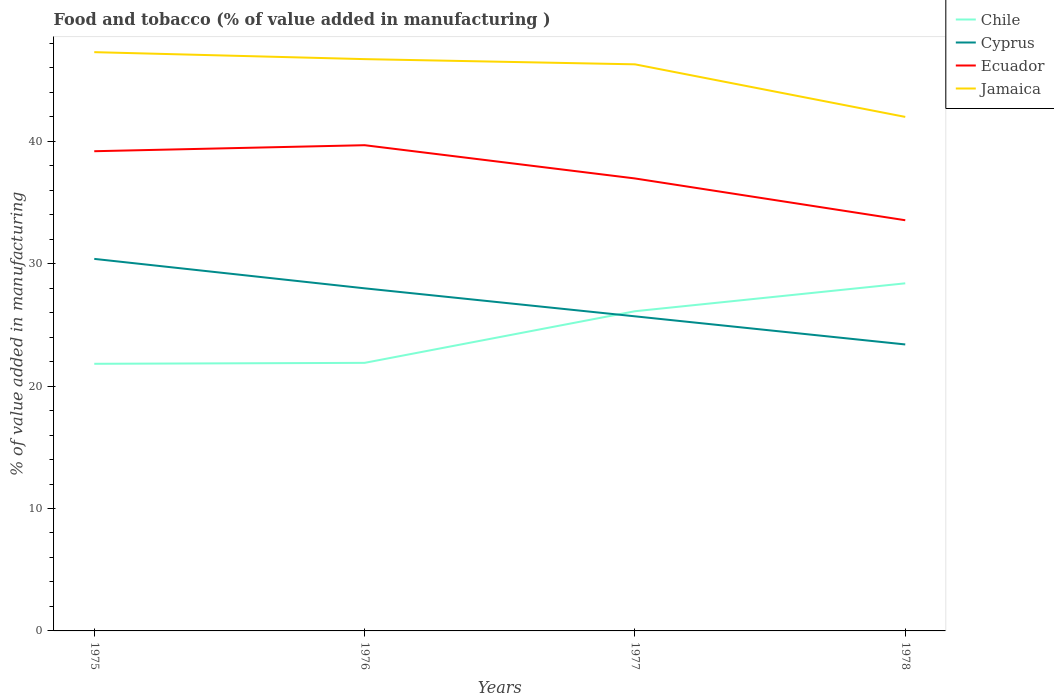How many different coloured lines are there?
Offer a very short reply. 4. Does the line corresponding to Jamaica intersect with the line corresponding to Chile?
Your response must be concise. No. Across all years, what is the maximum value added in manufacturing food and tobacco in Ecuador?
Offer a very short reply. 33.54. In which year was the value added in manufacturing food and tobacco in Chile maximum?
Your answer should be very brief. 1975. What is the total value added in manufacturing food and tobacco in Chile in the graph?
Offer a very short reply. -4.22. What is the difference between the highest and the second highest value added in manufacturing food and tobacco in Chile?
Your answer should be very brief. 6.57. What is the difference between the highest and the lowest value added in manufacturing food and tobacco in Ecuador?
Keep it short and to the point. 2. Is the value added in manufacturing food and tobacco in Jamaica strictly greater than the value added in manufacturing food and tobacco in Chile over the years?
Keep it short and to the point. No. How many lines are there?
Your response must be concise. 4. What is the difference between two consecutive major ticks on the Y-axis?
Your answer should be compact. 10. Where does the legend appear in the graph?
Your answer should be very brief. Top right. How are the legend labels stacked?
Make the answer very short. Vertical. What is the title of the graph?
Your answer should be very brief. Food and tobacco (% of value added in manufacturing ). Does "Vanuatu" appear as one of the legend labels in the graph?
Offer a very short reply. No. What is the label or title of the Y-axis?
Your answer should be very brief. % of value added in manufacturing. What is the % of value added in manufacturing of Chile in 1975?
Make the answer very short. 21.82. What is the % of value added in manufacturing of Cyprus in 1975?
Offer a terse response. 30.39. What is the % of value added in manufacturing in Ecuador in 1975?
Your answer should be very brief. 39.18. What is the % of value added in manufacturing of Jamaica in 1975?
Your response must be concise. 47.27. What is the % of value added in manufacturing in Chile in 1976?
Your response must be concise. 21.89. What is the % of value added in manufacturing of Cyprus in 1976?
Ensure brevity in your answer.  27.98. What is the % of value added in manufacturing in Ecuador in 1976?
Your answer should be very brief. 39.67. What is the % of value added in manufacturing in Jamaica in 1976?
Your answer should be very brief. 46.7. What is the % of value added in manufacturing in Chile in 1977?
Your answer should be compact. 26.11. What is the % of value added in manufacturing in Cyprus in 1977?
Give a very brief answer. 25.7. What is the % of value added in manufacturing of Ecuador in 1977?
Give a very brief answer. 36.96. What is the % of value added in manufacturing of Jamaica in 1977?
Keep it short and to the point. 46.28. What is the % of value added in manufacturing in Chile in 1978?
Provide a succinct answer. 28.39. What is the % of value added in manufacturing of Cyprus in 1978?
Provide a short and direct response. 23.4. What is the % of value added in manufacturing of Ecuador in 1978?
Keep it short and to the point. 33.54. What is the % of value added in manufacturing in Jamaica in 1978?
Offer a very short reply. 41.98. Across all years, what is the maximum % of value added in manufacturing in Chile?
Provide a succinct answer. 28.39. Across all years, what is the maximum % of value added in manufacturing in Cyprus?
Your answer should be compact. 30.39. Across all years, what is the maximum % of value added in manufacturing in Ecuador?
Offer a terse response. 39.67. Across all years, what is the maximum % of value added in manufacturing of Jamaica?
Your response must be concise. 47.27. Across all years, what is the minimum % of value added in manufacturing in Chile?
Ensure brevity in your answer.  21.82. Across all years, what is the minimum % of value added in manufacturing of Cyprus?
Give a very brief answer. 23.4. Across all years, what is the minimum % of value added in manufacturing of Ecuador?
Offer a terse response. 33.54. Across all years, what is the minimum % of value added in manufacturing in Jamaica?
Your response must be concise. 41.98. What is the total % of value added in manufacturing in Chile in the graph?
Ensure brevity in your answer.  98.22. What is the total % of value added in manufacturing in Cyprus in the graph?
Give a very brief answer. 107.46. What is the total % of value added in manufacturing of Ecuador in the graph?
Make the answer very short. 149.36. What is the total % of value added in manufacturing in Jamaica in the graph?
Keep it short and to the point. 182.24. What is the difference between the % of value added in manufacturing of Chile in 1975 and that in 1976?
Offer a terse response. -0.08. What is the difference between the % of value added in manufacturing of Cyprus in 1975 and that in 1976?
Give a very brief answer. 2.4. What is the difference between the % of value added in manufacturing of Ecuador in 1975 and that in 1976?
Give a very brief answer. -0.49. What is the difference between the % of value added in manufacturing in Jamaica in 1975 and that in 1976?
Ensure brevity in your answer.  0.57. What is the difference between the % of value added in manufacturing of Chile in 1975 and that in 1977?
Offer a terse response. -4.29. What is the difference between the % of value added in manufacturing of Cyprus in 1975 and that in 1977?
Keep it short and to the point. 4.69. What is the difference between the % of value added in manufacturing in Ecuador in 1975 and that in 1977?
Offer a terse response. 2.22. What is the difference between the % of value added in manufacturing in Chile in 1975 and that in 1978?
Offer a very short reply. -6.57. What is the difference between the % of value added in manufacturing in Cyprus in 1975 and that in 1978?
Provide a short and direct response. 6.99. What is the difference between the % of value added in manufacturing in Ecuador in 1975 and that in 1978?
Your response must be concise. 5.64. What is the difference between the % of value added in manufacturing of Jamaica in 1975 and that in 1978?
Make the answer very short. 5.29. What is the difference between the % of value added in manufacturing of Chile in 1976 and that in 1977?
Ensure brevity in your answer.  -4.22. What is the difference between the % of value added in manufacturing of Cyprus in 1976 and that in 1977?
Give a very brief answer. 2.29. What is the difference between the % of value added in manufacturing in Ecuador in 1976 and that in 1977?
Offer a very short reply. 2.72. What is the difference between the % of value added in manufacturing in Jamaica in 1976 and that in 1977?
Provide a short and direct response. 0.43. What is the difference between the % of value added in manufacturing in Chile in 1976 and that in 1978?
Provide a succinct answer. -6.5. What is the difference between the % of value added in manufacturing of Cyprus in 1976 and that in 1978?
Keep it short and to the point. 4.58. What is the difference between the % of value added in manufacturing of Ecuador in 1976 and that in 1978?
Ensure brevity in your answer.  6.13. What is the difference between the % of value added in manufacturing in Jamaica in 1976 and that in 1978?
Your answer should be compact. 4.72. What is the difference between the % of value added in manufacturing of Chile in 1977 and that in 1978?
Provide a succinct answer. -2.28. What is the difference between the % of value added in manufacturing of Cyprus in 1977 and that in 1978?
Offer a terse response. 2.3. What is the difference between the % of value added in manufacturing of Ecuador in 1977 and that in 1978?
Provide a short and direct response. 3.41. What is the difference between the % of value added in manufacturing in Jamaica in 1977 and that in 1978?
Ensure brevity in your answer.  4.29. What is the difference between the % of value added in manufacturing in Chile in 1975 and the % of value added in manufacturing in Cyprus in 1976?
Ensure brevity in your answer.  -6.16. What is the difference between the % of value added in manufacturing of Chile in 1975 and the % of value added in manufacturing of Ecuador in 1976?
Your answer should be compact. -17.85. What is the difference between the % of value added in manufacturing in Chile in 1975 and the % of value added in manufacturing in Jamaica in 1976?
Keep it short and to the point. -24.88. What is the difference between the % of value added in manufacturing in Cyprus in 1975 and the % of value added in manufacturing in Ecuador in 1976?
Your response must be concise. -9.29. What is the difference between the % of value added in manufacturing of Cyprus in 1975 and the % of value added in manufacturing of Jamaica in 1976?
Keep it short and to the point. -16.32. What is the difference between the % of value added in manufacturing in Ecuador in 1975 and the % of value added in manufacturing in Jamaica in 1976?
Your answer should be very brief. -7.52. What is the difference between the % of value added in manufacturing in Chile in 1975 and the % of value added in manufacturing in Cyprus in 1977?
Give a very brief answer. -3.88. What is the difference between the % of value added in manufacturing of Chile in 1975 and the % of value added in manufacturing of Ecuador in 1977?
Offer a very short reply. -15.14. What is the difference between the % of value added in manufacturing of Chile in 1975 and the % of value added in manufacturing of Jamaica in 1977?
Give a very brief answer. -24.46. What is the difference between the % of value added in manufacturing in Cyprus in 1975 and the % of value added in manufacturing in Ecuador in 1977?
Ensure brevity in your answer.  -6.57. What is the difference between the % of value added in manufacturing in Cyprus in 1975 and the % of value added in manufacturing in Jamaica in 1977?
Provide a short and direct response. -15.89. What is the difference between the % of value added in manufacturing in Ecuador in 1975 and the % of value added in manufacturing in Jamaica in 1977?
Keep it short and to the point. -7.1. What is the difference between the % of value added in manufacturing in Chile in 1975 and the % of value added in manufacturing in Cyprus in 1978?
Offer a terse response. -1.58. What is the difference between the % of value added in manufacturing in Chile in 1975 and the % of value added in manufacturing in Ecuador in 1978?
Your answer should be compact. -11.73. What is the difference between the % of value added in manufacturing in Chile in 1975 and the % of value added in manufacturing in Jamaica in 1978?
Ensure brevity in your answer.  -20.16. What is the difference between the % of value added in manufacturing of Cyprus in 1975 and the % of value added in manufacturing of Ecuador in 1978?
Offer a terse response. -3.16. What is the difference between the % of value added in manufacturing in Cyprus in 1975 and the % of value added in manufacturing in Jamaica in 1978?
Provide a short and direct response. -11.6. What is the difference between the % of value added in manufacturing of Ecuador in 1975 and the % of value added in manufacturing of Jamaica in 1978?
Give a very brief answer. -2.8. What is the difference between the % of value added in manufacturing of Chile in 1976 and the % of value added in manufacturing of Cyprus in 1977?
Make the answer very short. -3.8. What is the difference between the % of value added in manufacturing in Chile in 1976 and the % of value added in manufacturing in Ecuador in 1977?
Your answer should be very brief. -15.06. What is the difference between the % of value added in manufacturing in Chile in 1976 and the % of value added in manufacturing in Jamaica in 1977?
Provide a succinct answer. -24.38. What is the difference between the % of value added in manufacturing in Cyprus in 1976 and the % of value added in manufacturing in Ecuador in 1977?
Give a very brief answer. -8.97. What is the difference between the % of value added in manufacturing of Cyprus in 1976 and the % of value added in manufacturing of Jamaica in 1977?
Keep it short and to the point. -18.3. What is the difference between the % of value added in manufacturing of Ecuador in 1976 and the % of value added in manufacturing of Jamaica in 1977?
Offer a terse response. -6.61. What is the difference between the % of value added in manufacturing of Chile in 1976 and the % of value added in manufacturing of Cyprus in 1978?
Ensure brevity in your answer.  -1.5. What is the difference between the % of value added in manufacturing in Chile in 1976 and the % of value added in manufacturing in Ecuador in 1978?
Provide a short and direct response. -11.65. What is the difference between the % of value added in manufacturing of Chile in 1976 and the % of value added in manufacturing of Jamaica in 1978?
Provide a short and direct response. -20.09. What is the difference between the % of value added in manufacturing of Cyprus in 1976 and the % of value added in manufacturing of Ecuador in 1978?
Provide a succinct answer. -5.56. What is the difference between the % of value added in manufacturing of Cyprus in 1976 and the % of value added in manufacturing of Jamaica in 1978?
Provide a succinct answer. -14. What is the difference between the % of value added in manufacturing in Ecuador in 1976 and the % of value added in manufacturing in Jamaica in 1978?
Ensure brevity in your answer.  -2.31. What is the difference between the % of value added in manufacturing in Chile in 1977 and the % of value added in manufacturing in Cyprus in 1978?
Provide a short and direct response. 2.71. What is the difference between the % of value added in manufacturing of Chile in 1977 and the % of value added in manufacturing of Ecuador in 1978?
Your answer should be compact. -7.43. What is the difference between the % of value added in manufacturing in Chile in 1977 and the % of value added in manufacturing in Jamaica in 1978?
Make the answer very short. -15.87. What is the difference between the % of value added in manufacturing in Cyprus in 1977 and the % of value added in manufacturing in Ecuador in 1978?
Ensure brevity in your answer.  -7.85. What is the difference between the % of value added in manufacturing in Cyprus in 1977 and the % of value added in manufacturing in Jamaica in 1978?
Provide a short and direct response. -16.29. What is the difference between the % of value added in manufacturing of Ecuador in 1977 and the % of value added in manufacturing of Jamaica in 1978?
Offer a very short reply. -5.03. What is the average % of value added in manufacturing in Chile per year?
Offer a very short reply. 24.55. What is the average % of value added in manufacturing in Cyprus per year?
Provide a short and direct response. 26.87. What is the average % of value added in manufacturing in Ecuador per year?
Offer a terse response. 37.34. What is the average % of value added in manufacturing of Jamaica per year?
Make the answer very short. 45.56. In the year 1975, what is the difference between the % of value added in manufacturing in Chile and % of value added in manufacturing in Cyprus?
Provide a short and direct response. -8.57. In the year 1975, what is the difference between the % of value added in manufacturing in Chile and % of value added in manufacturing in Ecuador?
Your answer should be compact. -17.36. In the year 1975, what is the difference between the % of value added in manufacturing in Chile and % of value added in manufacturing in Jamaica?
Offer a terse response. -25.45. In the year 1975, what is the difference between the % of value added in manufacturing in Cyprus and % of value added in manufacturing in Ecuador?
Your response must be concise. -8.79. In the year 1975, what is the difference between the % of value added in manufacturing in Cyprus and % of value added in manufacturing in Jamaica?
Your response must be concise. -16.89. In the year 1975, what is the difference between the % of value added in manufacturing of Ecuador and % of value added in manufacturing of Jamaica?
Ensure brevity in your answer.  -8.09. In the year 1976, what is the difference between the % of value added in manufacturing in Chile and % of value added in manufacturing in Cyprus?
Your response must be concise. -6.09. In the year 1976, what is the difference between the % of value added in manufacturing in Chile and % of value added in manufacturing in Ecuador?
Make the answer very short. -17.78. In the year 1976, what is the difference between the % of value added in manufacturing in Chile and % of value added in manufacturing in Jamaica?
Your answer should be compact. -24.81. In the year 1976, what is the difference between the % of value added in manufacturing in Cyprus and % of value added in manufacturing in Ecuador?
Provide a short and direct response. -11.69. In the year 1976, what is the difference between the % of value added in manufacturing of Cyprus and % of value added in manufacturing of Jamaica?
Ensure brevity in your answer.  -18.72. In the year 1976, what is the difference between the % of value added in manufacturing of Ecuador and % of value added in manufacturing of Jamaica?
Your answer should be compact. -7.03. In the year 1977, what is the difference between the % of value added in manufacturing in Chile and % of value added in manufacturing in Cyprus?
Offer a terse response. 0.42. In the year 1977, what is the difference between the % of value added in manufacturing in Chile and % of value added in manufacturing in Ecuador?
Your answer should be compact. -10.85. In the year 1977, what is the difference between the % of value added in manufacturing of Chile and % of value added in manufacturing of Jamaica?
Your answer should be very brief. -20.17. In the year 1977, what is the difference between the % of value added in manufacturing in Cyprus and % of value added in manufacturing in Ecuador?
Provide a short and direct response. -11.26. In the year 1977, what is the difference between the % of value added in manufacturing in Cyprus and % of value added in manufacturing in Jamaica?
Keep it short and to the point. -20.58. In the year 1977, what is the difference between the % of value added in manufacturing of Ecuador and % of value added in manufacturing of Jamaica?
Keep it short and to the point. -9.32. In the year 1978, what is the difference between the % of value added in manufacturing of Chile and % of value added in manufacturing of Cyprus?
Ensure brevity in your answer.  4.99. In the year 1978, what is the difference between the % of value added in manufacturing of Chile and % of value added in manufacturing of Ecuador?
Your answer should be compact. -5.15. In the year 1978, what is the difference between the % of value added in manufacturing in Chile and % of value added in manufacturing in Jamaica?
Provide a succinct answer. -13.59. In the year 1978, what is the difference between the % of value added in manufacturing in Cyprus and % of value added in manufacturing in Ecuador?
Offer a terse response. -10.15. In the year 1978, what is the difference between the % of value added in manufacturing in Cyprus and % of value added in manufacturing in Jamaica?
Your answer should be compact. -18.59. In the year 1978, what is the difference between the % of value added in manufacturing of Ecuador and % of value added in manufacturing of Jamaica?
Provide a succinct answer. -8.44. What is the ratio of the % of value added in manufacturing of Cyprus in 1975 to that in 1976?
Your answer should be compact. 1.09. What is the ratio of the % of value added in manufacturing of Ecuador in 1975 to that in 1976?
Your answer should be compact. 0.99. What is the ratio of the % of value added in manufacturing of Jamaica in 1975 to that in 1976?
Keep it short and to the point. 1.01. What is the ratio of the % of value added in manufacturing in Chile in 1975 to that in 1977?
Give a very brief answer. 0.84. What is the ratio of the % of value added in manufacturing of Cyprus in 1975 to that in 1977?
Offer a very short reply. 1.18. What is the ratio of the % of value added in manufacturing in Ecuador in 1975 to that in 1977?
Provide a short and direct response. 1.06. What is the ratio of the % of value added in manufacturing of Jamaica in 1975 to that in 1977?
Your answer should be compact. 1.02. What is the ratio of the % of value added in manufacturing of Chile in 1975 to that in 1978?
Your response must be concise. 0.77. What is the ratio of the % of value added in manufacturing of Cyprus in 1975 to that in 1978?
Make the answer very short. 1.3. What is the ratio of the % of value added in manufacturing in Ecuador in 1975 to that in 1978?
Ensure brevity in your answer.  1.17. What is the ratio of the % of value added in manufacturing of Jamaica in 1975 to that in 1978?
Your answer should be compact. 1.13. What is the ratio of the % of value added in manufacturing in Chile in 1976 to that in 1977?
Offer a very short reply. 0.84. What is the ratio of the % of value added in manufacturing of Cyprus in 1976 to that in 1977?
Ensure brevity in your answer.  1.09. What is the ratio of the % of value added in manufacturing of Ecuador in 1976 to that in 1977?
Ensure brevity in your answer.  1.07. What is the ratio of the % of value added in manufacturing of Jamaica in 1976 to that in 1977?
Give a very brief answer. 1.01. What is the ratio of the % of value added in manufacturing in Chile in 1976 to that in 1978?
Your response must be concise. 0.77. What is the ratio of the % of value added in manufacturing in Cyprus in 1976 to that in 1978?
Your response must be concise. 1.2. What is the ratio of the % of value added in manufacturing of Ecuador in 1976 to that in 1978?
Give a very brief answer. 1.18. What is the ratio of the % of value added in manufacturing in Jamaica in 1976 to that in 1978?
Provide a short and direct response. 1.11. What is the ratio of the % of value added in manufacturing of Chile in 1977 to that in 1978?
Offer a very short reply. 0.92. What is the ratio of the % of value added in manufacturing in Cyprus in 1977 to that in 1978?
Provide a short and direct response. 1.1. What is the ratio of the % of value added in manufacturing of Ecuador in 1977 to that in 1978?
Keep it short and to the point. 1.1. What is the ratio of the % of value added in manufacturing in Jamaica in 1977 to that in 1978?
Your answer should be compact. 1.1. What is the difference between the highest and the second highest % of value added in manufacturing of Chile?
Your answer should be compact. 2.28. What is the difference between the highest and the second highest % of value added in manufacturing in Cyprus?
Your answer should be compact. 2.4. What is the difference between the highest and the second highest % of value added in manufacturing in Ecuador?
Make the answer very short. 0.49. What is the difference between the highest and the second highest % of value added in manufacturing of Jamaica?
Your response must be concise. 0.57. What is the difference between the highest and the lowest % of value added in manufacturing in Chile?
Your answer should be compact. 6.57. What is the difference between the highest and the lowest % of value added in manufacturing in Cyprus?
Your response must be concise. 6.99. What is the difference between the highest and the lowest % of value added in manufacturing of Ecuador?
Provide a succinct answer. 6.13. What is the difference between the highest and the lowest % of value added in manufacturing of Jamaica?
Your answer should be compact. 5.29. 